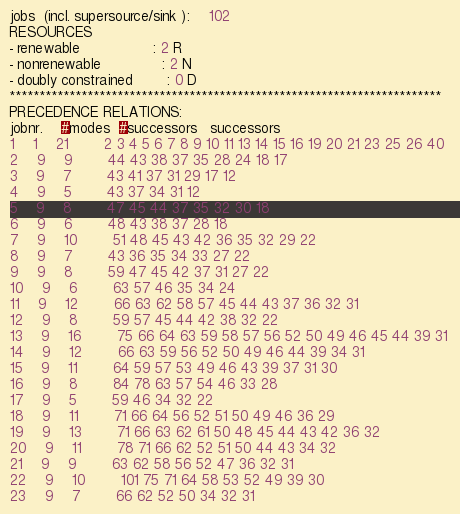<code> <loc_0><loc_0><loc_500><loc_500><_ObjectiveC_>jobs  (incl. supersource/sink ):	102
RESOURCES
- renewable                 : 2 R
- nonrenewable              : 2 N
- doubly constrained        : 0 D
************************************************************************
PRECEDENCE RELATIONS:
jobnr.    #modes  #successors   successors
1	1	21		2 3 4 5 6 7 8 9 10 11 13 14 15 16 19 20 21 23 25 26 40 
2	9	9		44 43 38 37 35 28 24 18 17 
3	9	7		43 41 37 31 29 17 12 
4	9	5		43 37 34 31 12 
5	9	8		47 45 44 37 35 32 30 18 
6	9	6		48 43 38 37 28 18 
7	9	10		51 48 45 43 42 36 35 32 29 22 
8	9	7		43 36 35 34 33 27 22 
9	9	8		59 47 45 42 37 31 27 22 
10	9	6		63 57 46 35 34 24 
11	9	12		66 63 62 58 57 45 44 43 37 36 32 31 
12	9	8		59 57 45 44 42 38 32 22 
13	9	16		75 66 64 63 59 58 57 56 52 50 49 46 45 44 39 31 
14	9	12		66 63 59 56 52 50 49 46 44 39 34 31 
15	9	11		64 59 57 53 49 46 43 39 37 31 30 
16	9	8		84 78 63 57 54 46 33 28 
17	9	5		59 46 34 32 22 
18	9	11		71 66 64 56 52 51 50 49 46 36 29 
19	9	13		71 66 63 62 61 50 48 45 44 43 42 36 32 
20	9	11		78 71 66 62 52 51 50 44 43 34 32 
21	9	9		63 62 58 56 52 47 36 32 31 
22	9	10		101 75 71 64 58 53 52 49 39 30 
23	9	7		66 62 52 50 34 32 31 </code> 